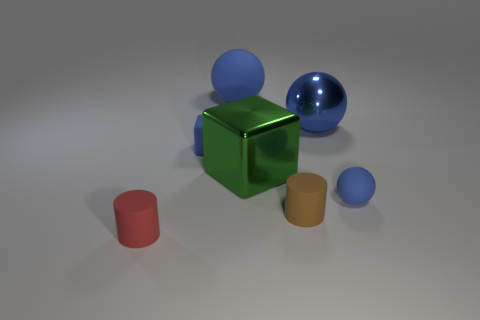How many blue balls must be subtracted to get 1 blue balls? 2 Add 3 rubber cylinders. How many objects exist? 10 Subtract all large blue spheres. How many spheres are left? 1 Subtract all balls. How many objects are left? 4 Subtract all red cubes. Subtract all brown cylinders. How many cubes are left? 2 Subtract all green blocks. How many red cylinders are left? 1 Subtract all brown rubber objects. Subtract all big metallic blocks. How many objects are left? 5 Add 3 tiny rubber objects. How many tiny rubber objects are left? 7 Add 3 metal things. How many metal things exist? 5 Subtract 0 blue cylinders. How many objects are left? 7 